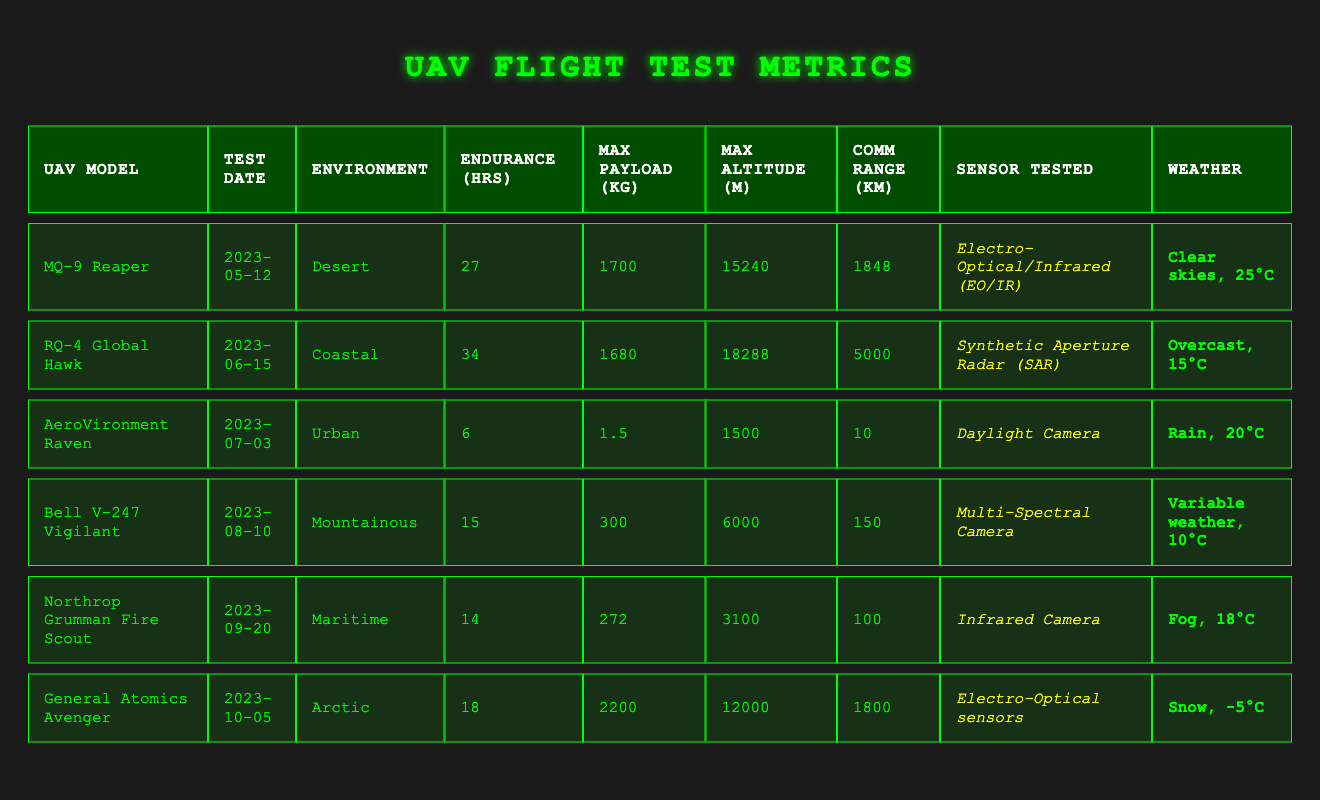What is the maximum payload capacity of the MQ-9 Reaper? The maximum payload capacity is listed in the table under the "Max Payload (kg)" column for the MQ-9 Reaper, which shows 1700 kg.
Answer: 1700 kg In which environment was the RQ-4 Global Hawk tested? The environment for the RQ-4 Global Hawk is specified in the "Environment" column in the table, which states "Coastal."
Answer: Coastal What was the endurance time of the AeroVironment Raven? The endurance time for the AeroVironment Raven is found in the "Endurance (hrs)" column of the table, which indicates 6 hours.
Answer: 6 hours Which UAV tested had the highest communication range? The communication range is compared across all UAVs in the "Comm Range (km)" column. The RQ-4 Global Hawk has the highest communication range of 5000 km.
Answer: 5000 km What is the average endurance time across all tested UAVs? To find the average endurance time, sum the endurance hours: (27 + 34 + 6 + 15 + 14 + 18) = 114. There are 6 UAVs, so the average endurance is 114 / 6 = 19 hours.
Answer: 19 hours True or False: The General Atomics Avenger had a higher maximum altitude than the Bell V-247 Vigilant. The "Max Altitude (m)" column shows that the General Atomics Avenger has a maximum altitude of 12000 m, while the Bell V-247 Vigilant has 6000 m. Therefore, the statement is true.
Answer: True What was the weather condition during the flight test of the Northrop Grumman Fire Scout? The weather condition is listed under the "Weather" column for the Northrop Grumman Fire Scout test, which states "Fog, 18°C."
Answer: Fog, 18°C Which UAV model had the shortest endurance time and what was that duration? The "Endurance (hrs)" column shows that the AeroVironment Raven had the shortest endurance time of 6 hours.
Answer: AeroVironment Raven, 6 hours How does the maximum payload of the General Atomics Avenger compare to that of the Northrop Grumman Fire Scout? The "Max Payload (kg)" column indicates that the General Atomics Avenger has a maximum payload of 2200 kg, while the Northrop Grumman Fire Scout has 272 kg. The Avenger has a significantly higher payload compared to the Fire Scout.
Answer: Higher What is the difference in maximum altitude between the RQ-4 Global Hawk and the AeroVironment Raven? The maximum altitude for the RQ-4 Global Hawk is 18288 m and for the AeroVironment Raven is 1500 m. The difference is 18288 - 1500 = 16788 m.
Answer: 16788 m Which UAV has the highest maximum altitude and what is that altitude? Checking the "Max Altitude (m)" column reveals that the RQ-4 Global Hawk has the highest maximum altitude of 18288 m.
Answer: 18288 m 